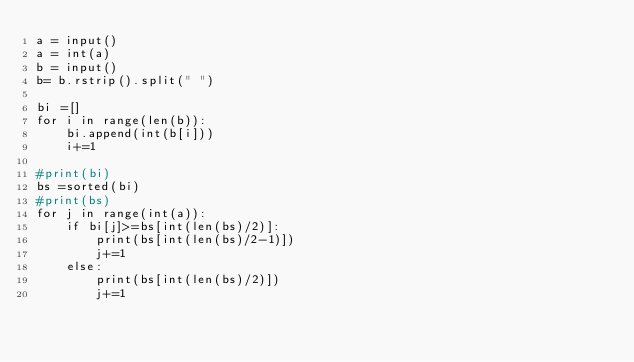<code> <loc_0><loc_0><loc_500><loc_500><_Python_>a = input()
a = int(a)
b = input()
b= b.rstrip().split(" ")

bi =[]
for i in range(len(b)):
    bi.append(int(b[i]))
    i+=1
    
#print(bi)
bs =sorted(bi)
#print(bs)
for j in range(int(a)):
    if bi[j]>=bs[int(len(bs)/2)]:
        print(bs[int(len(bs)/2-1)])
        j+=1
    else:
        print(bs[int(len(bs)/2)])
        j+=1</code> 